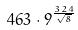<formula> <loc_0><loc_0><loc_500><loc_500>4 6 3 \cdot 9 ^ { \frac { 3 2 4 } { \sqrt { 8 } } }</formula> 